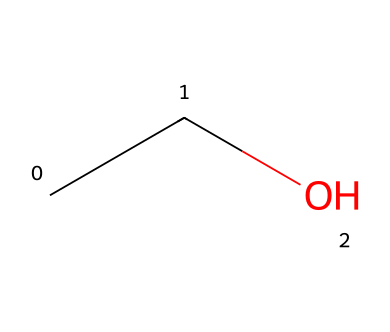What is the name of this chemical? The provided SMILES representation "CCO" corresponds to ethanol, which is a simple alcohol. The two carbon atoms (CC) and the hydroxyl group (O) indicate that it is ethanol.
Answer: ethanol How many carbon atoms are there in ethanol? The SMILES notation "CCO" shows two carbon atoms represented by "CC." Therefore, we can count the carbon atoms present.
Answer: 2 What type of compound is ethanol? Ethanol is classified as an aliphatic compound because it consists of straight-chain carbon atoms and lacks any aromatic structures. The presence of single C-C bonds and the hydroxyl group confirm this classification.
Answer: aliphatic How many hydrogen atoms are in ethanol? To determine the number of hydrogen atoms, we consider the two carbon atoms, which are associated with five hydrogen atoms in total due to the bonding arrangement (C2H5OH). Therefore, ethanol has a total of six hydrogen atoms.
Answer: 6 What is the functional group in ethanol? The functional group in ethanol is the hydroxyl group (-OH), which is indicated by the oxygen atom connected to a carbon atom in the SMILES representation. This hydroxyl group characterizes ethanol as an alcohol.
Answer: hydroxyl What is the total number of bonds in ethanol? Ethanol has a total of 5 bonds: 1 bond between each carbon atom (1 bond), 3 bonds between carbon and hydrogen (3 bonds), and 1 bond between one carbon and the oxygen (1 bond). This adds up to 5 bonds in total.
Answer: 5 